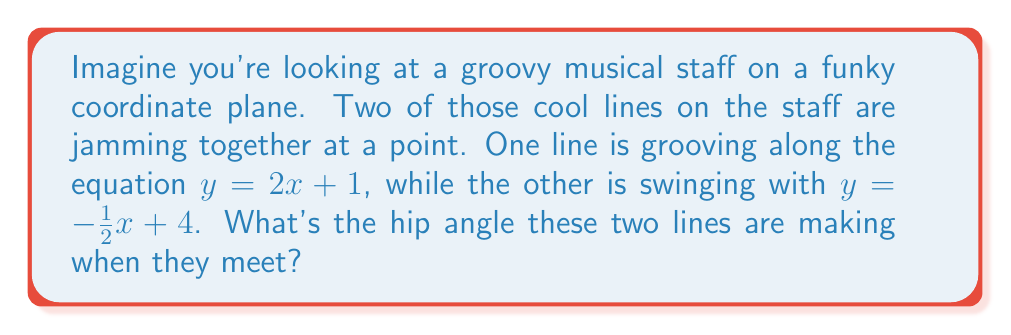Can you solve this math problem? Alright, let's break this down into a smooth jazz session:

1. We've got two lines with different rhythms (slopes). To find the angle between them, we'll use the groovy formula:

   $$\tan \theta = \left|\frac{m_1 - m_2}{1 + m_1m_2}\right|$$

   Where $m_1$ and $m_2$ are the slopes of our two lines.

2. Let's identify the slopes:
   - For $y = 2x + 1$, the slope $m_1 = 2$
   - For $y = -\frac{1}{2}x + 4$, the slope $m_2 = -\frac{1}{2}$

3. Now, let's plug these into our formula:

   $$\tan \theta = \left|\frac{2 - (-\frac{1}{2})}{1 + 2(-\frac{1}{2})}\right| = \left|\frac{2 + \frac{1}{2}}{1 - 1}\right| = \left|\frac{\frac{5}{2}}{0}\right|$$

4. Simplify:
   $$\tan \theta = \frac{5}{2} = 2.5$$

5. To find the actual angle, we need to use the inverse tangent (arctan):

   $$\theta = \arctan(2.5)$$

6. Using a calculator or math table, we find:

   $$\theta \approx 68.20^\circ$$

That's the hip angle our staff lines are making!
Answer: $68.20^\circ$ 